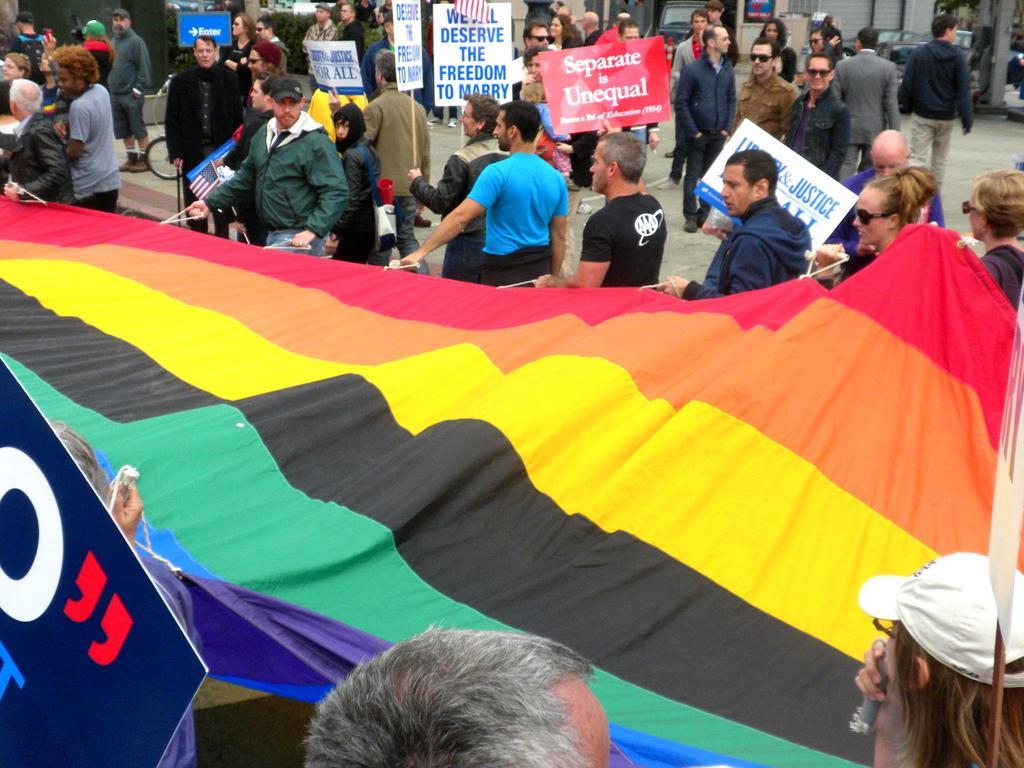Describe this image in one or two sentences. In this image the front there are persons. In the center there is banner which is holded by the persons. In the background there are persons standing and holding placards with some text written on it and there are vehicles, plants and there is a wall. 